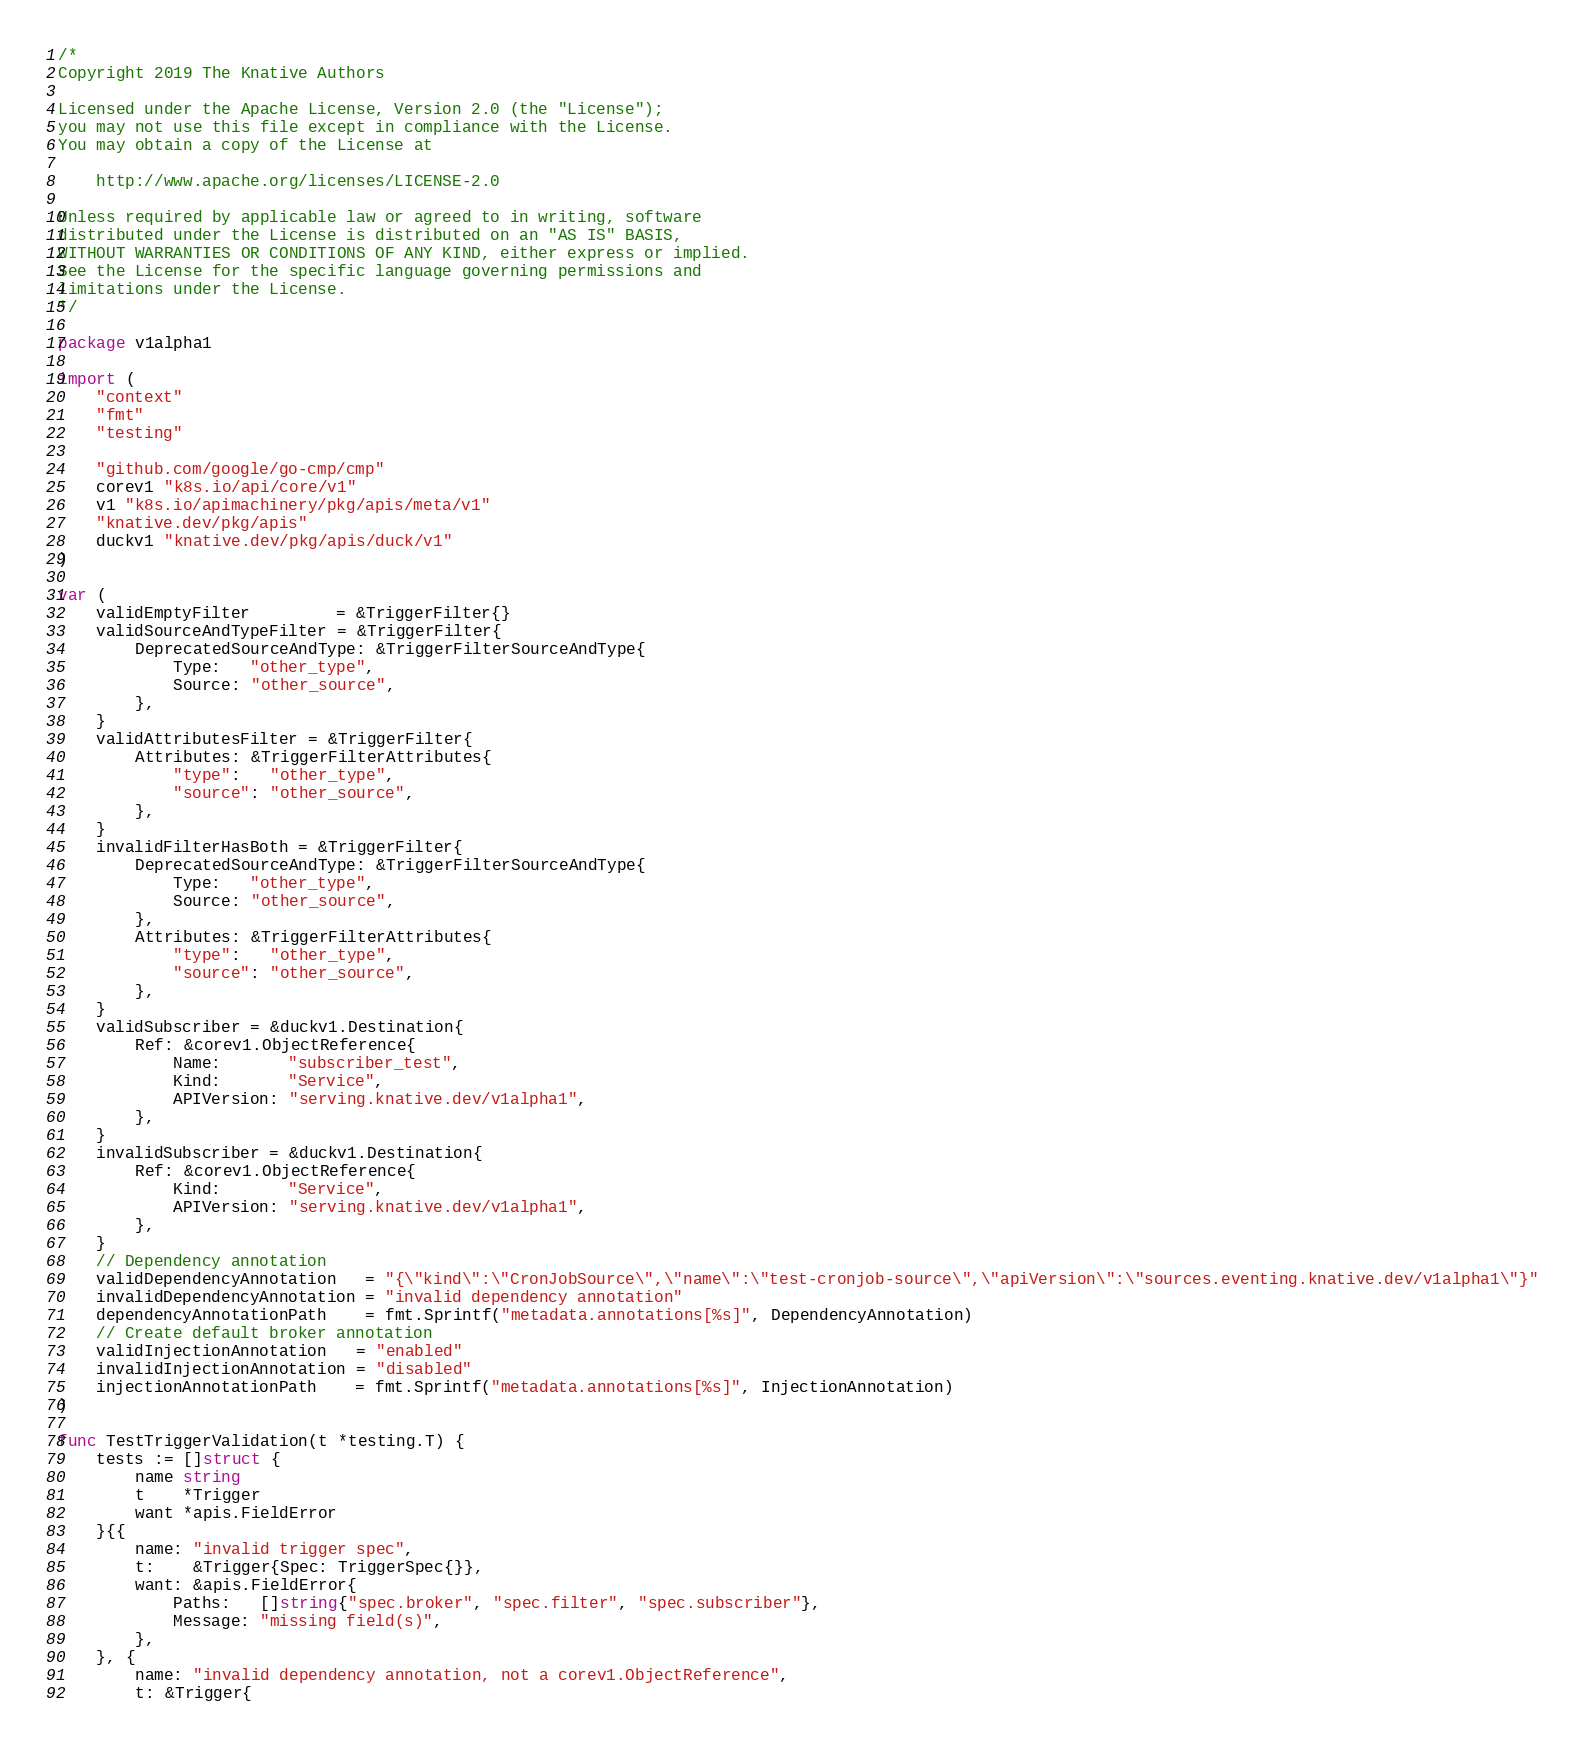Convert code to text. <code><loc_0><loc_0><loc_500><loc_500><_Go_>/*
Copyright 2019 The Knative Authors

Licensed under the Apache License, Version 2.0 (the "License");
you may not use this file except in compliance with the License.
You may obtain a copy of the License at

    http://www.apache.org/licenses/LICENSE-2.0

Unless required by applicable law or agreed to in writing, software
distributed under the License is distributed on an "AS IS" BASIS,
WITHOUT WARRANTIES OR CONDITIONS OF ANY KIND, either express or implied.
See the License for the specific language governing permissions and
limitations under the License.
*/

package v1alpha1

import (
	"context"
	"fmt"
	"testing"

	"github.com/google/go-cmp/cmp"
	corev1 "k8s.io/api/core/v1"
	v1 "k8s.io/apimachinery/pkg/apis/meta/v1"
	"knative.dev/pkg/apis"
	duckv1 "knative.dev/pkg/apis/duck/v1"
)

var (
	validEmptyFilter         = &TriggerFilter{}
	validSourceAndTypeFilter = &TriggerFilter{
		DeprecatedSourceAndType: &TriggerFilterSourceAndType{
			Type:   "other_type",
			Source: "other_source",
		},
	}
	validAttributesFilter = &TriggerFilter{
		Attributes: &TriggerFilterAttributes{
			"type":   "other_type",
			"source": "other_source",
		},
	}
	invalidFilterHasBoth = &TriggerFilter{
		DeprecatedSourceAndType: &TriggerFilterSourceAndType{
			Type:   "other_type",
			Source: "other_source",
		},
		Attributes: &TriggerFilterAttributes{
			"type":   "other_type",
			"source": "other_source",
		},
	}
	validSubscriber = &duckv1.Destination{
		Ref: &corev1.ObjectReference{
			Name:       "subscriber_test",
			Kind:       "Service",
			APIVersion: "serving.knative.dev/v1alpha1",
		},
	}
	invalidSubscriber = &duckv1.Destination{
		Ref: &corev1.ObjectReference{
			Kind:       "Service",
			APIVersion: "serving.knative.dev/v1alpha1",
		},
	}
	// Dependency annotation
	validDependencyAnnotation   = "{\"kind\":\"CronJobSource\",\"name\":\"test-cronjob-source\",\"apiVersion\":\"sources.eventing.knative.dev/v1alpha1\"}"
	invalidDependencyAnnotation = "invalid dependency annotation"
	dependencyAnnotationPath    = fmt.Sprintf("metadata.annotations[%s]", DependencyAnnotation)
	// Create default broker annotation
	validInjectionAnnotation   = "enabled"
	invalidInjectionAnnotation = "disabled"
	injectionAnnotationPath    = fmt.Sprintf("metadata.annotations[%s]", InjectionAnnotation)
)

func TestTriggerValidation(t *testing.T) {
	tests := []struct {
		name string
		t    *Trigger
		want *apis.FieldError
	}{{
		name: "invalid trigger spec",
		t:    &Trigger{Spec: TriggerSpec{}},
		want: &apis.FieldError{
			Paths:   []string{"spec.broker", "spec.filter", "spec.subscriber"},
			Message: "missing field(s)",
		},
	}, {
		name: "invalid dependency annotation, not a corev1.ObjectReference",
		t: &Trigger{</code> 